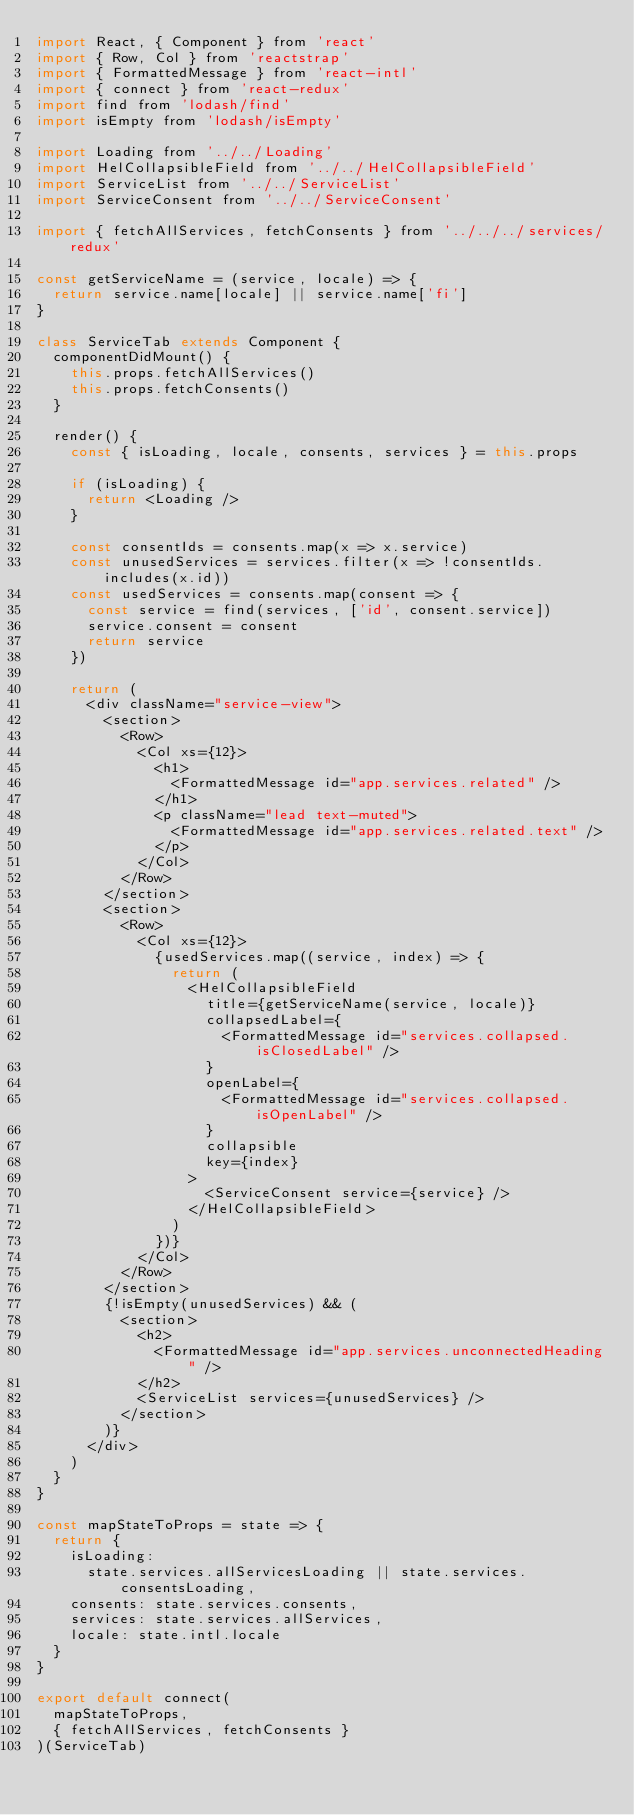Convert code to text. <code><loc_0><loc_0><loc_500><loc_500><_JavaScript_>import React, { Component } from 'react'
import { Row, Col } from 'reactstrap'
import { FormattedMessage } from 'react-intl'
import { connect } from 'react-redux'
import find from 'lodash/find'
import isEmpty from 'lodash/isEmpty'

import Loading from '../../Loading'
import HelCollapsibleField from '../../HelCollapsibleField'
import ServiceList from '../../ServiceList'
import ServiceConsent from '../../ServiceConsent'

import { fetchAllServices, fetchConsents } from '../../../services/redux'

const getServiceName = (service, locale) => {
  return service.name[locale] || service.name['fi']
}

class ServiceTab extends Component {
  componentDidMount() {
    this.props.fetchAllServices()
    this.props.fetchConsents()
  }

  render() {
    const { isLoading, locale, consents, services } = this.props

    if (isLoading) {
      return <Loading />
    }

    const consentIds = consents.map(x => x.service)
    const unusedServices = services.filter(x => !consentIds.includes(x.id))
    const usedServices = consents.map(consent => {
      const service = find(services, ['id', consent.service])
      service.consent = consent
      return service
    })

    return (
      <div className="service-view">
        <section>
          <Row>
            <Col xs={12}>
              <h1>
                <FormattedMessage id="app.services.related" />
              </h1>
              <p className="lead text-muted">
                <FormattedMessage id="app.services.related.text" />
              </p>
            </Col>
          </Row>
        </section>
        <section>
          <Row>
            <Col xs={12}>
              {usedServices.map((service, index) => {
                return (
                  <HelCollapsibleField
                    title={getServiceName(service, locale)}
                    collapsedLabel={
                      <FormattedMessage id="services.collapsed.isClosedLabel" />
                    }
                    openLabel={
                      <FormattedMessage id="services.collapsed.isOpenLabel" />
                    }
                    collapsible
                    key={index}
                  >
                    <ServiceConsent service={service} />
                  </HelCollapsibleField>
                )
              })}
            </Col>
          </Row>
        </section>
        {!isEmpty(unusedServices) && (
          <section>
            <h2>
              <FormattedMessage id="app.services.unconnectedHeading" />
            </h2>
            <ServiceList services={unusedServices} />
          </section>
        )}
      </div>
    )
  }
}

const mapStateToProps = state => {
  return {
    isLoading:
      state.services.allServicesLoading || state.services.consentsLoading,
    consents: state.services.consents,
    services: state.services.allServices,
    locale: state.intl.locale
  }
}

export default connect(
  mapStateToProps,
  { fetchAllServices, fetchConsents }
)(ServiceTab)
</code> 